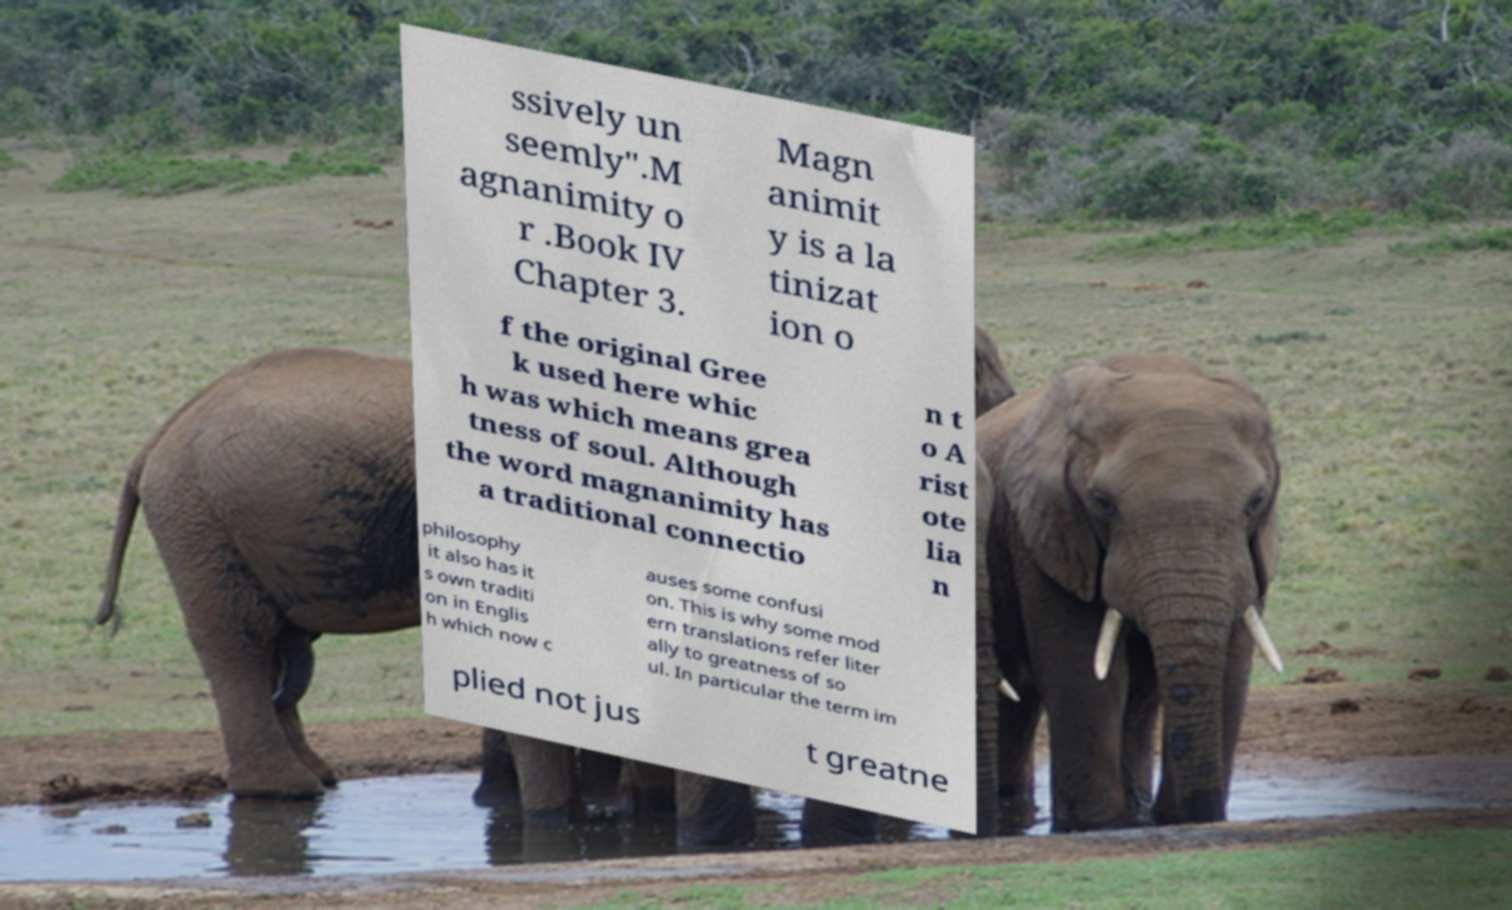For documentation purposes, I need the text within this image transcribed. Could you provide that? ssively un seemly".M agnanimity o r .Book IV Chapter 3. Magn animit y is a la tinizat ion o f the original Gree k used here whic h was which means grea tness of soul. Although the word magnanimity has a traditional connectio n t o A rist ote lia n philosophy it also has it s own traditi on in Englis h which now c auses some confusi on. This is why some mod ern translations refer liter ally to greatness of so ul. In particular the term im plied not jus t greatne 